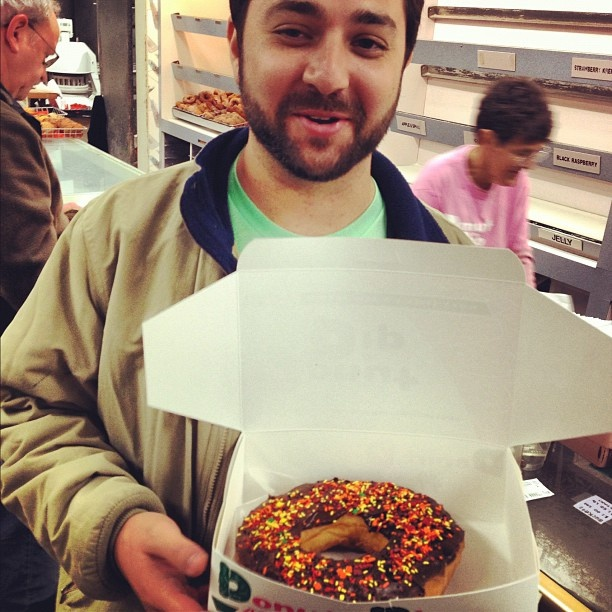Describe the objects in this image and their specific colors. I can see people in gray, tan, brown, black, and maroon tones, donut in gray, maroon, brown, and black tones, people in gray, lightpink, black, maroon, and brown tones, people in gray, black, brown, and maroon tones, and donut in gray, tan, salmon, and brown tones in this image. 